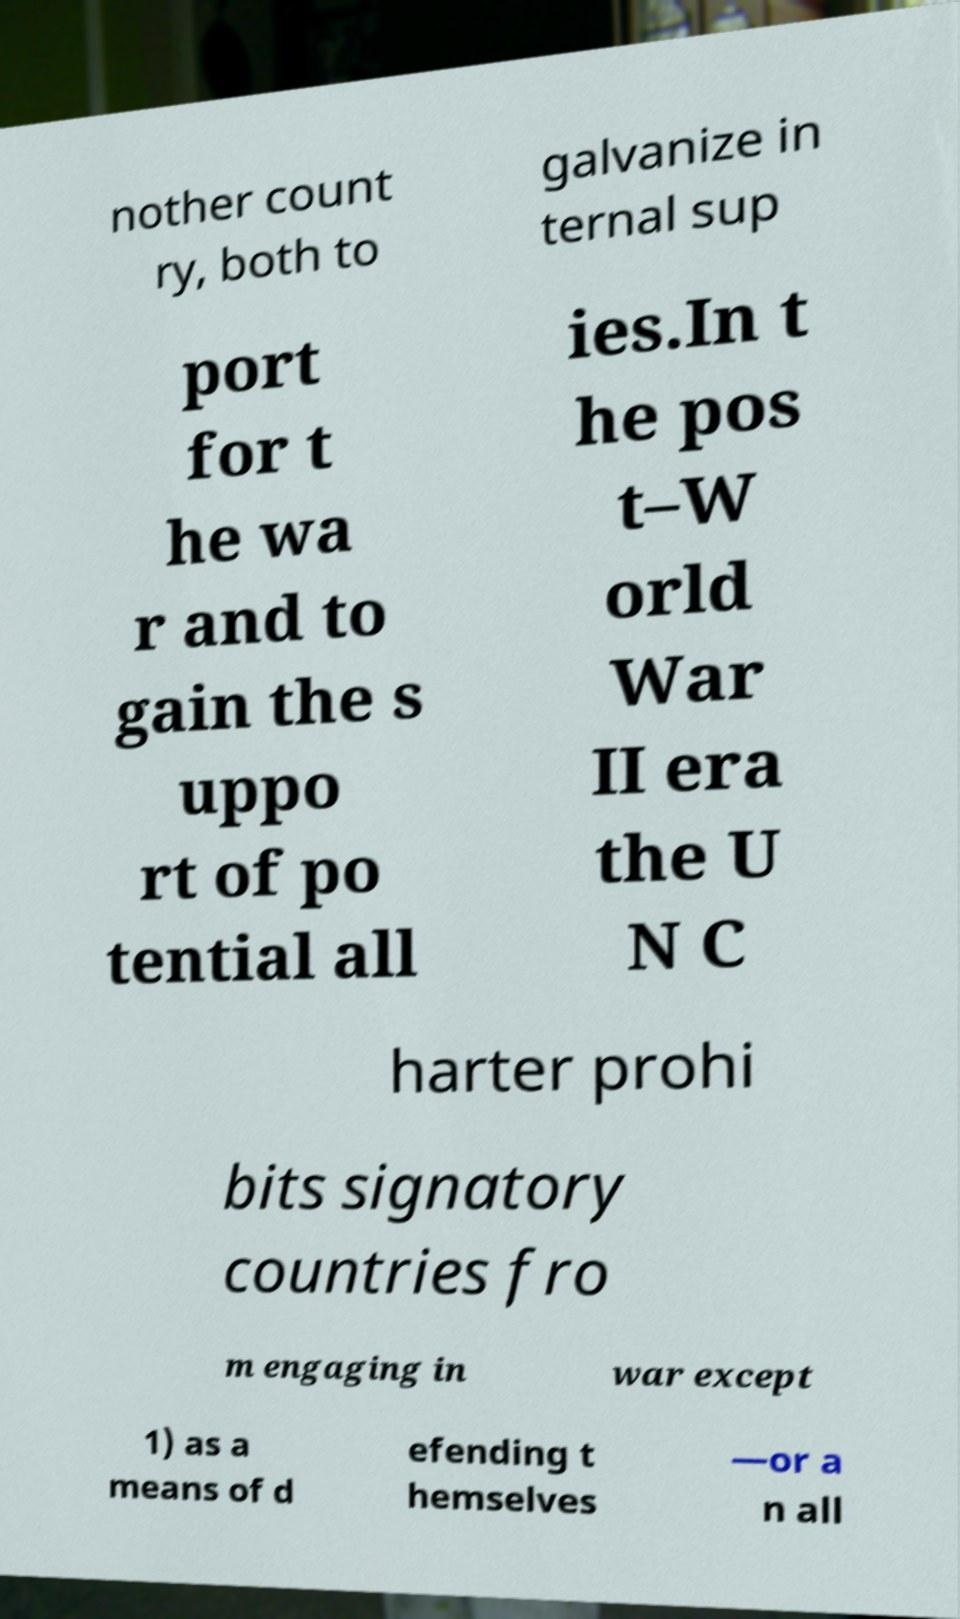Can you read and provide the text displayed in the image?This photo seems to have some interesting text. Can you extract and type it out for me? nother count ry, both to galvanize in ternal sup port for t he wa r and to gain the s uppo rt of po tential all ies.In t he pos t–W orld War II era the U N C harter prohi bits signatory countries fro m engaging in war except 1) as a means of d efending t hemselves —or a n all 